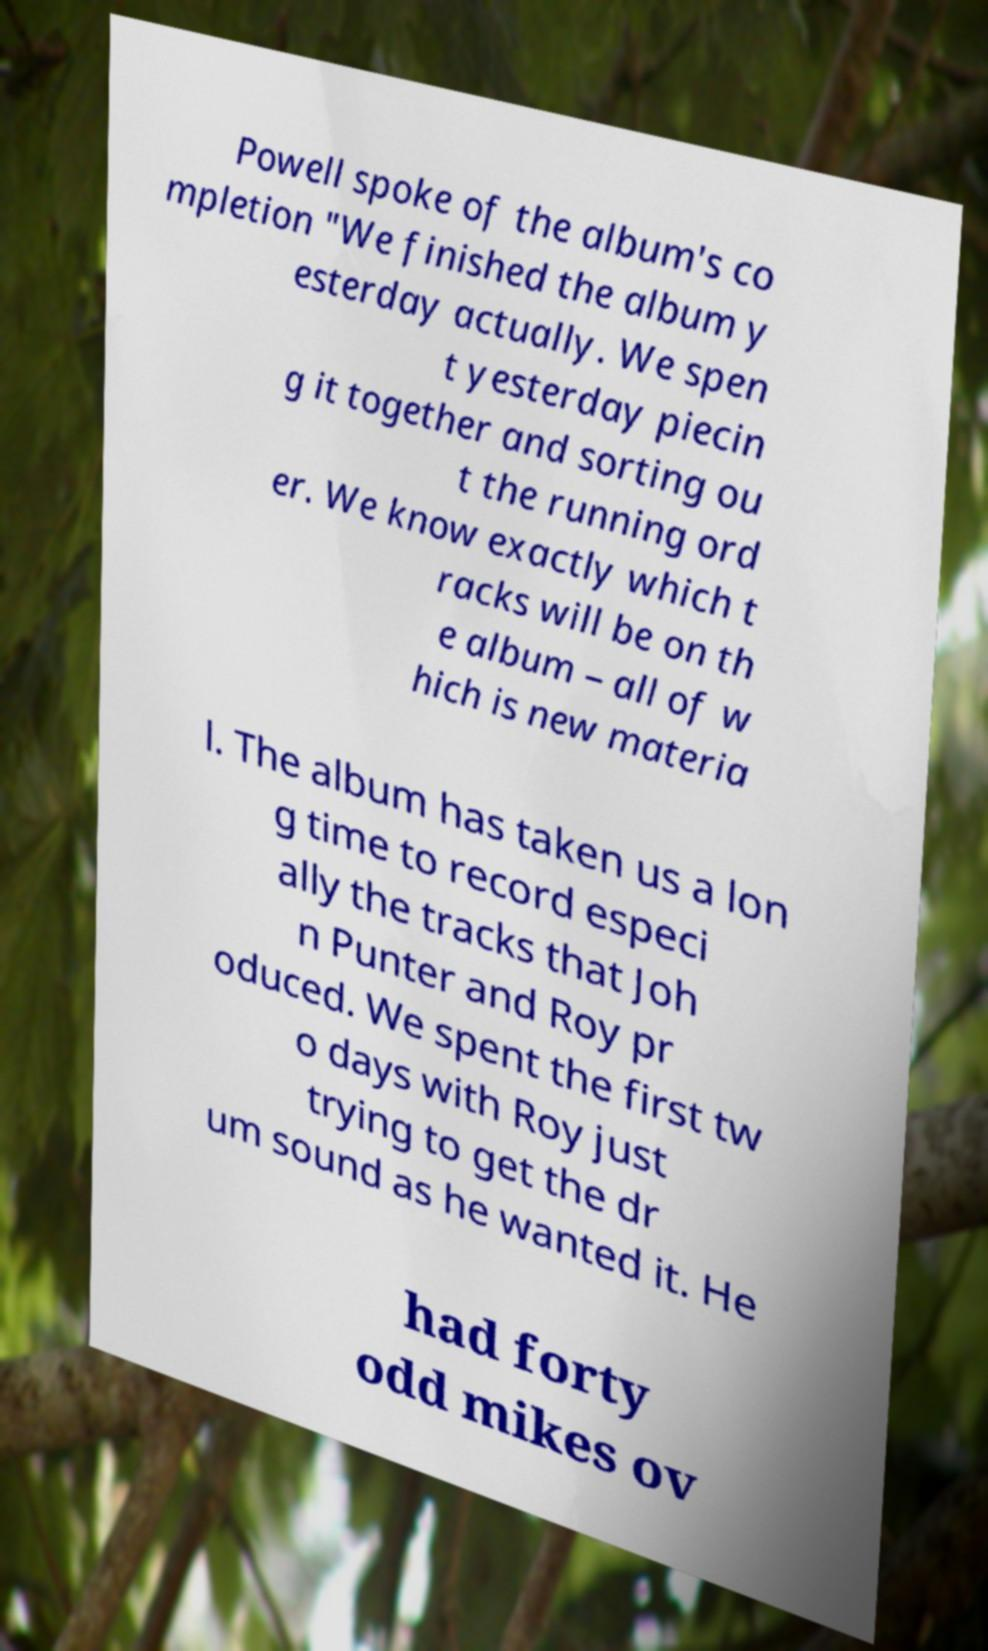Can you read and provide the text displayed in the image?This photo seems to have some interesting text. Can you extract and type it out for me? Powell spoke of the album's co mpletion "We finished the album y esterday actually. We spen t yesterday piecin g it together and sorting ou t the running ord er. We know exactly which t racks will be on th e album – all of w hich is new materia l. The album has taken us a lon g time to record especi ally the tracks that Joh n Punter and Roy pr oduced. We spent the first tw o days with Roy just trying to get the dr um sound as he wanted it. He had forty odd mikes ov 